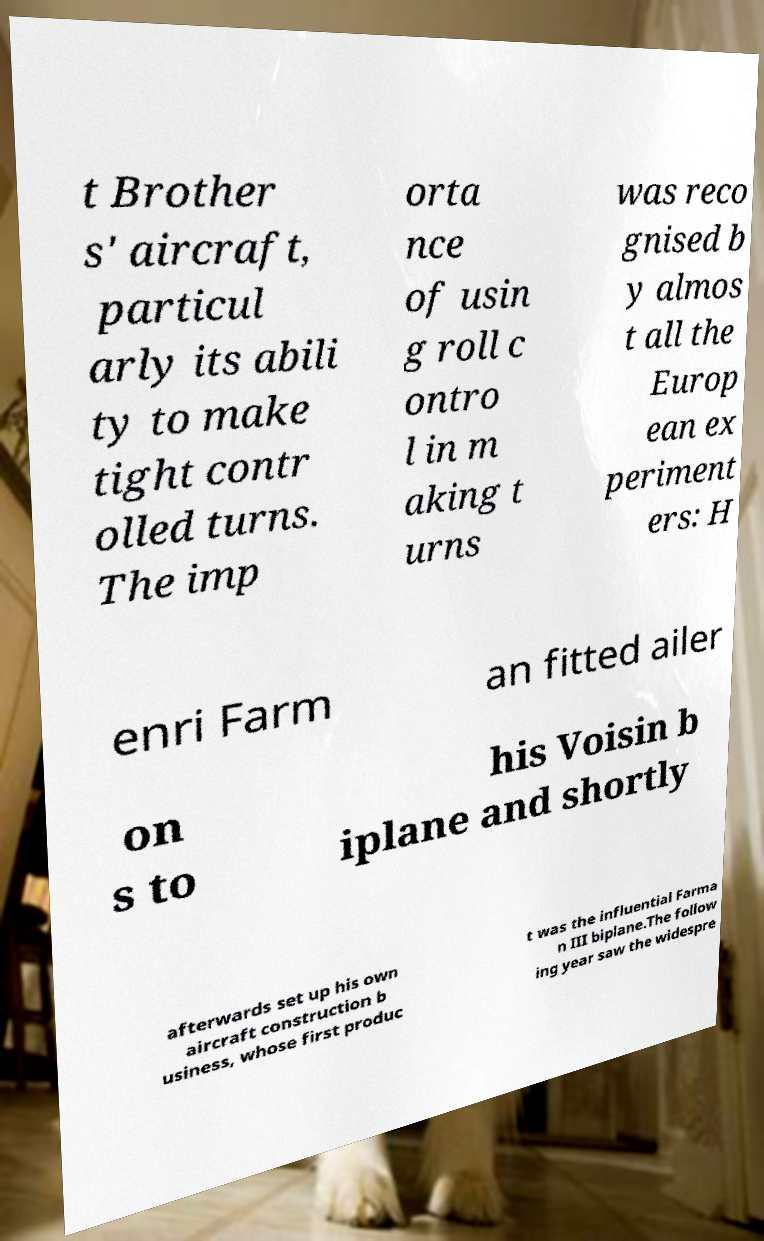Can you read and provide the text displayed in the image?This photo seems to have some interesting text. Can you extract and type it out for me? t Brother s' aircraft, particul arly its abili ty to make tight contr olled turns. The imp orta nce of usin g roll c ontro l in m aking t urns was reco gnised b y almos t all the Europ ean ex periment ers: H enri Farm an fitted ailer on s to his Voisin b iplane and shortly afterwards set up his own aircraft construction b usiness, whose first produc t was the influential Farma n III biplane.The follow ing year saw the widespre 